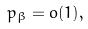<formula> <loc_0><loc_0><loc_500><loc_500>p _ { \beta } = o ( 1 ) ,</formula> 